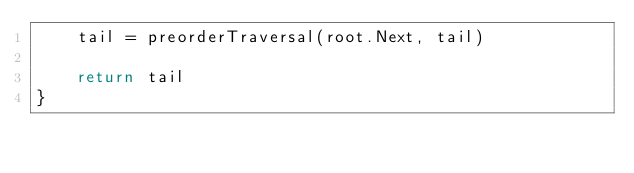Convert code to text. <code><loc_0><loc_0><loc_500><loc_500><_Go_>	tail = preorderTraversal(root.Next, tail)

	return tail
}
</code> 